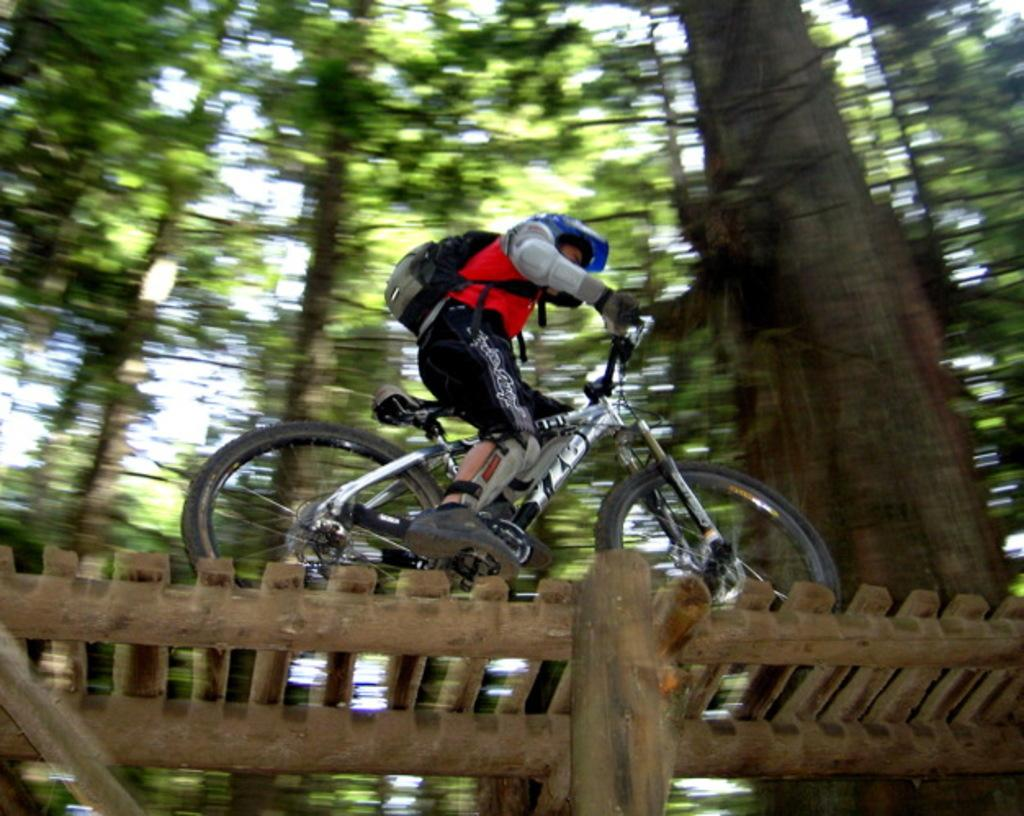What is the person in the image doing? The person is riding a bicycle in the image. What is the surface on which the bicycle is being ridden? The bicycle is on a wooden path. What can be seen in the background of the image? There are trees and the sky visible in the background of the image. Where is the shade provided for the person riding the bicycle in the image? There is no specific shade mentioned or visible in the image; the person is riding a bicycle on a wooden path with trees and the sky visible in the background. 